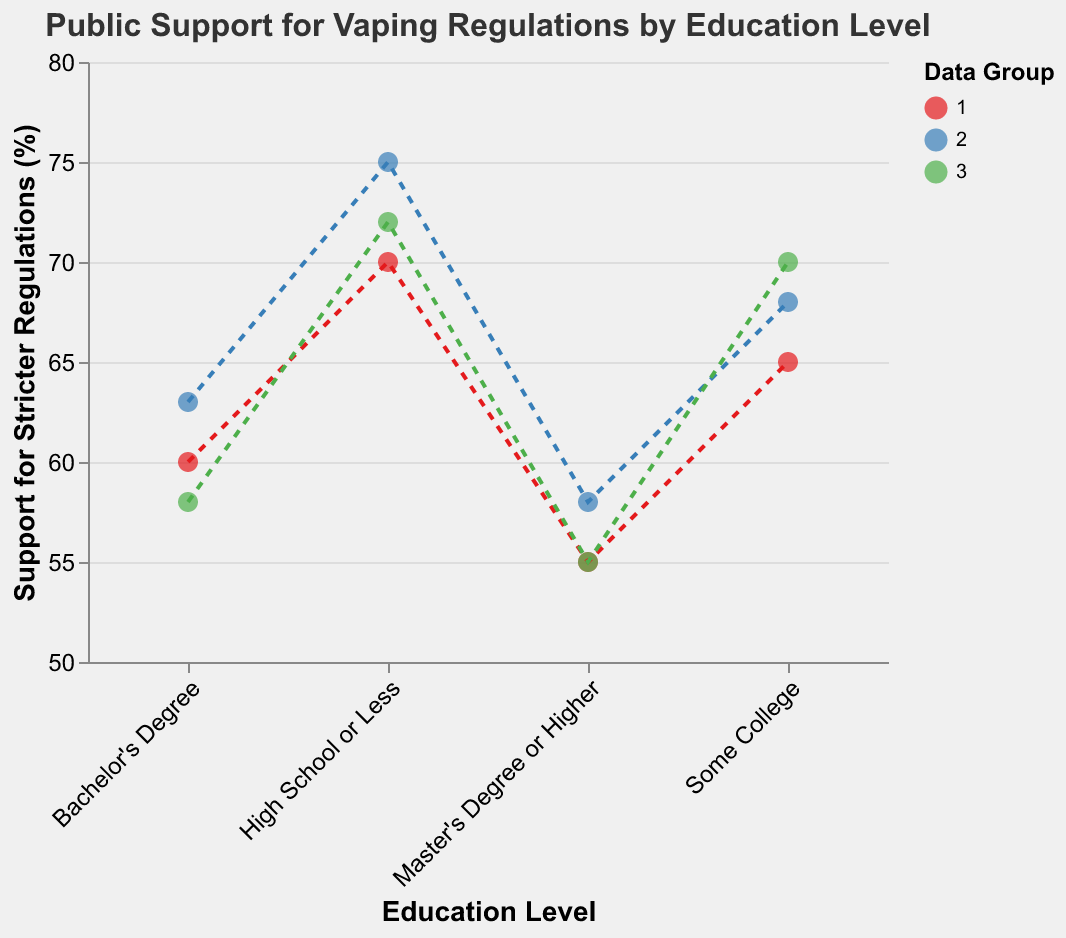What is the title of the plot? The title of a plot is typically located at the top and provides a brief description of the visualized data. In this case, it reads "Public Support for Vaping Regulations by Education Level."
Answer: Public Support for Vaping Regulations by Education Level How many educational levels are represented in the plot? By examining the x-axis, we see the different categories which correspond to who supports vaping regulations, namely: "High School or Less," "Some College," "Bachelor's Degree," and "Master's Degree or Higher." There are four educational levels represented.
Answer: Four Which educational level shows the highest support for stricter vaping regulations in all data groups? By inspecting the y-values for each education level across all groups and identifying the highest percentage, "High School or Less" consistently shows the highest values for support across all groups with values around 70%, 75%, and 72%.
Answer: High School or Less What is the trend in support for stricter regulations as education level increases? Observing the points plotted for support across different education levels shows a clear downward trend. As the education level increases from "High School or Less" to "Master's Degree or Higher," the support for stricter regulations consistently decreases.
Answer: Decreases How many data groups are shown in the plot? The legend identifies the distinct groups with three colors. Yellow for Group 1, blue for Group 2, and green for Group 3, indicating there are three groups in the plot.
Answer: Three What's the range of support for stricter regulations across all education levels and groups? The highest value of support seen is 75% ("High School or Less" in Group 2) and the lowest is 55% ("Master's Degree or Higher" in Groups 1 and 3). Therefore, the range is 75% - 55% = 20%.
Answer: 20% Which group has the highest opposition to stricter vaping regulations for the "Bachelor's Degree" education level? Look at the data points for the "Bachelor's Degree" education level across all groups for the highest "Opposition to Stricter Regulations" percentage. Group 1 has the highest opposition value at 42%.
Answer: Group 1 What is the average support for stricter vaping regulations among those with a "Master's Degree or Higher"? To calculate the average, sum the support percentages for all groups at this education level and divide by the number of groups: (55 + 58 + 55) / 3 = 56%.
Answer: 56% Which educational level has the least variation in the support for stricter regulations? Variation can be observed by looking at the spread of the y-values for each education level across different groups. "Master's Degree or Higher" has values of 55%, 58%, and 55%, indicating the smallest spread of just 3%.
Answer: Master's Degree or Higher Between "Some College" and "Bachelor's Degree," which showed a greater decrease in support for stricter regulations? For "Some College," values are: 65%, 68%, 70%. For "Bachelor's Degree," values are: 60%, 63%, 58%. To find the greater decrease, compare the range for each: "Some College" decreased from 70% to 65% (5%), and "Bachelor's Degree" decreased from 63% to 58% (5%). Both show a similar decrease, but "Bachelor's Degree" saw an overall slightly larger drop from its highest observed support value.
Answer: Bachelor's Degree 